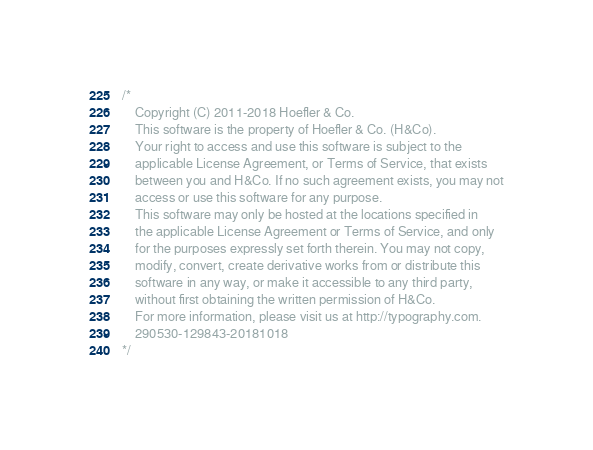Convert code to text. <code><loc_0><loc_0><loc_500><loc_500><_CSS_>
/*
	Copyright (C) 2011-2018 Hoefler & Co.
	This software is the property of Hoefler & Co. (H&Co).
	Your right to access and use this software is subject to the
	applicable License Agreement, or Terms of Service, that exists
	between you and H&Co. If no such agreement exists, you may not
	access or use this software for any purpose.
	This software may only be hosted at the locations specified in
	the applicable License Agreement or Terms of Service, and only
	for the purposes expressly set forth therein. You may not copy,
	modify, convert, create derivative works from or distribute this
	software in any way, or make it accessible to any third party,
	without first obtaining the written permission of H&Co.
	For more information, please visit us at http://typography.com.
	290530-129843-20181018
*/
</code> 